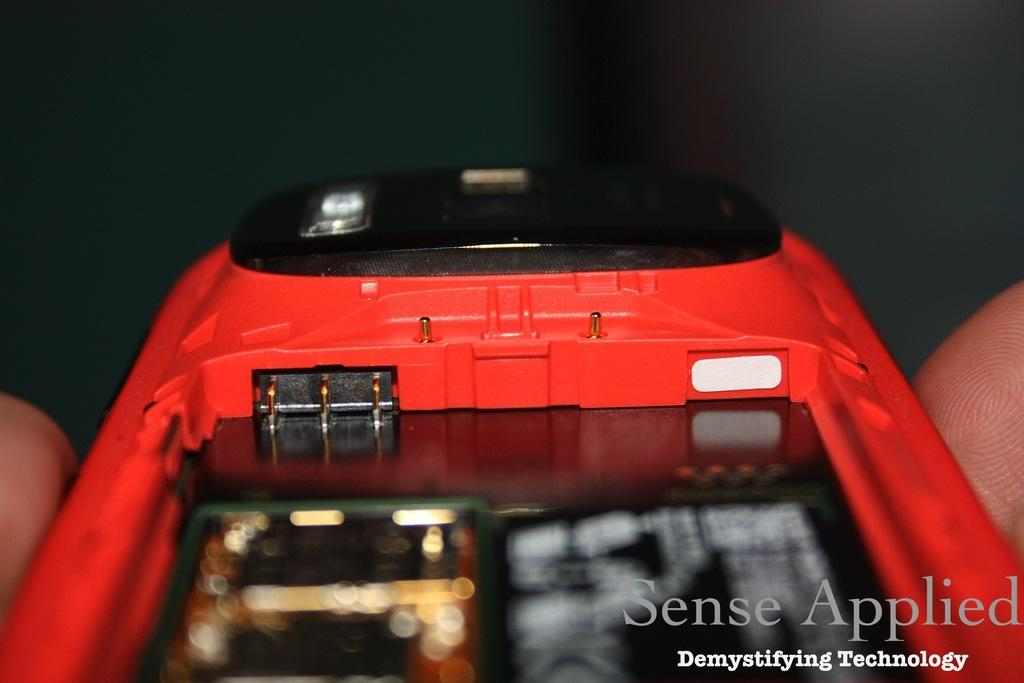<image>
Summarize the visual content of the image. A picture of a red device is shown with a Sense Applied watermark in the corner. 